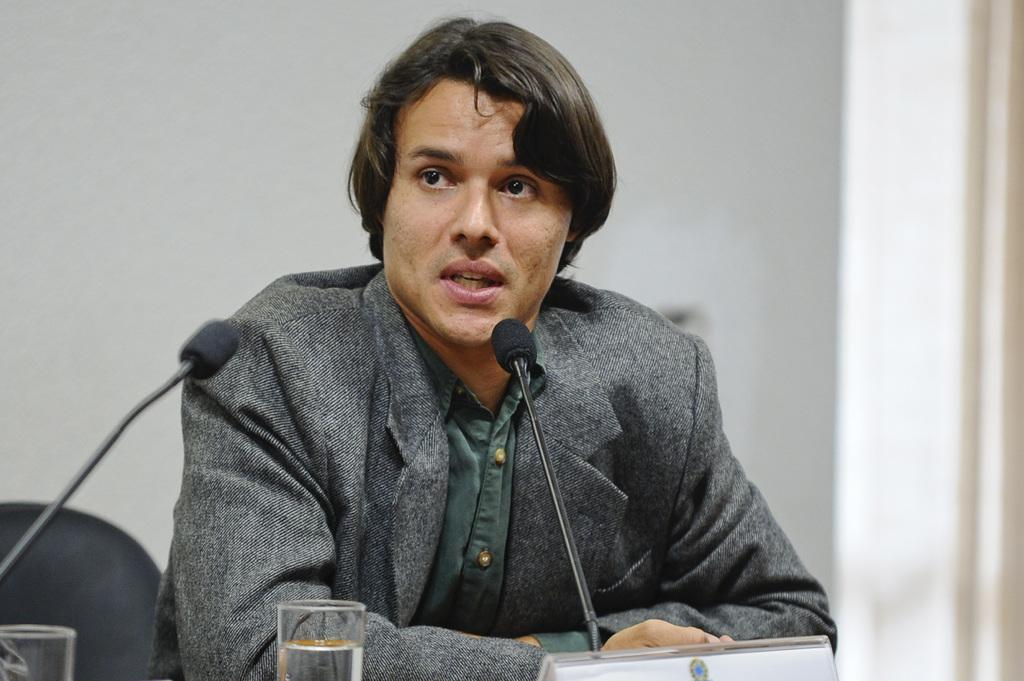Who is present in the image? There is a man in the image. What object can be seen in the image that is typically used for holding liquids? There is a mug in the image. What type of eyewear is visible in the image? There are glasses in the image. What type of furniture is present in the image? There is a chair in the image. What type of loaf is being offered to the man in the image? There is no loaf present in the image. What sign can be seen in the image indicating the location or purpose of the setting? There is no sign present in the image. 